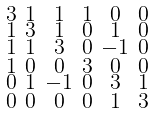<formula> <loc_0><loc_0><loc_500><loc_500>\begin{smallmatrix} 3 & 1 & 1 & 1 & 0 & 0 \\ 1 & 3 & 1 & 0 & 1 & 0 \\ 1 & 1 & 3 & 0 & - 1 & 0 \\ 1 & 0 & 0 & 3 & 0 & 0 \\ 0 & 1 & - 1 & 0 & 3 & 1 \\ 0 & 0 & 0 & 0 & 1 & 3 \end{smallmatrix}</formula> 